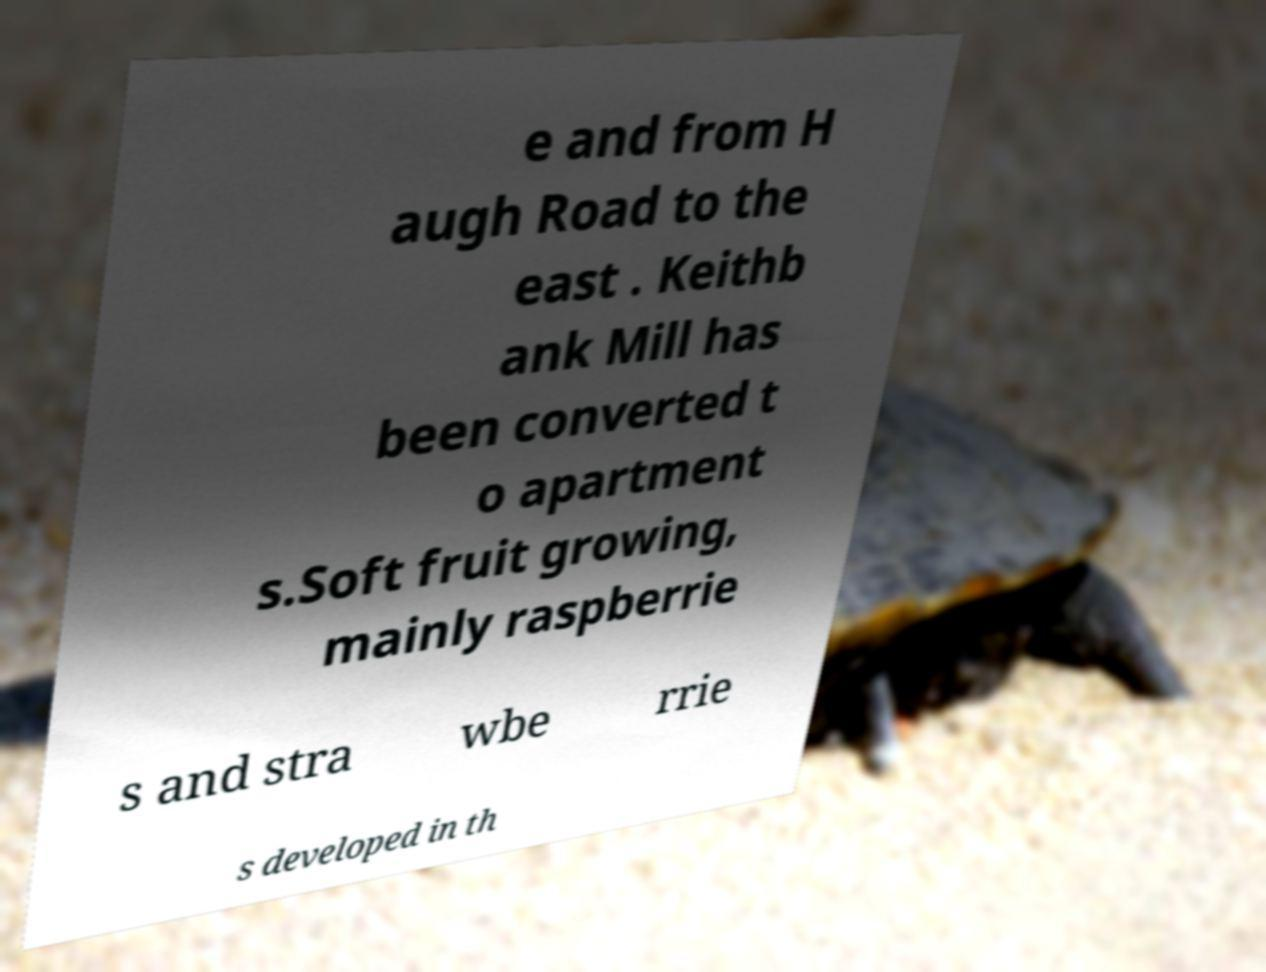Could you assist in decoding the text presented in this image and type it out clearly? e and from H augh Road to the east . Keithb ank Mill has been converted t o apartment s.Soft fruit growing, mainly raspberrie s and stra wbe rrie s developed in th 